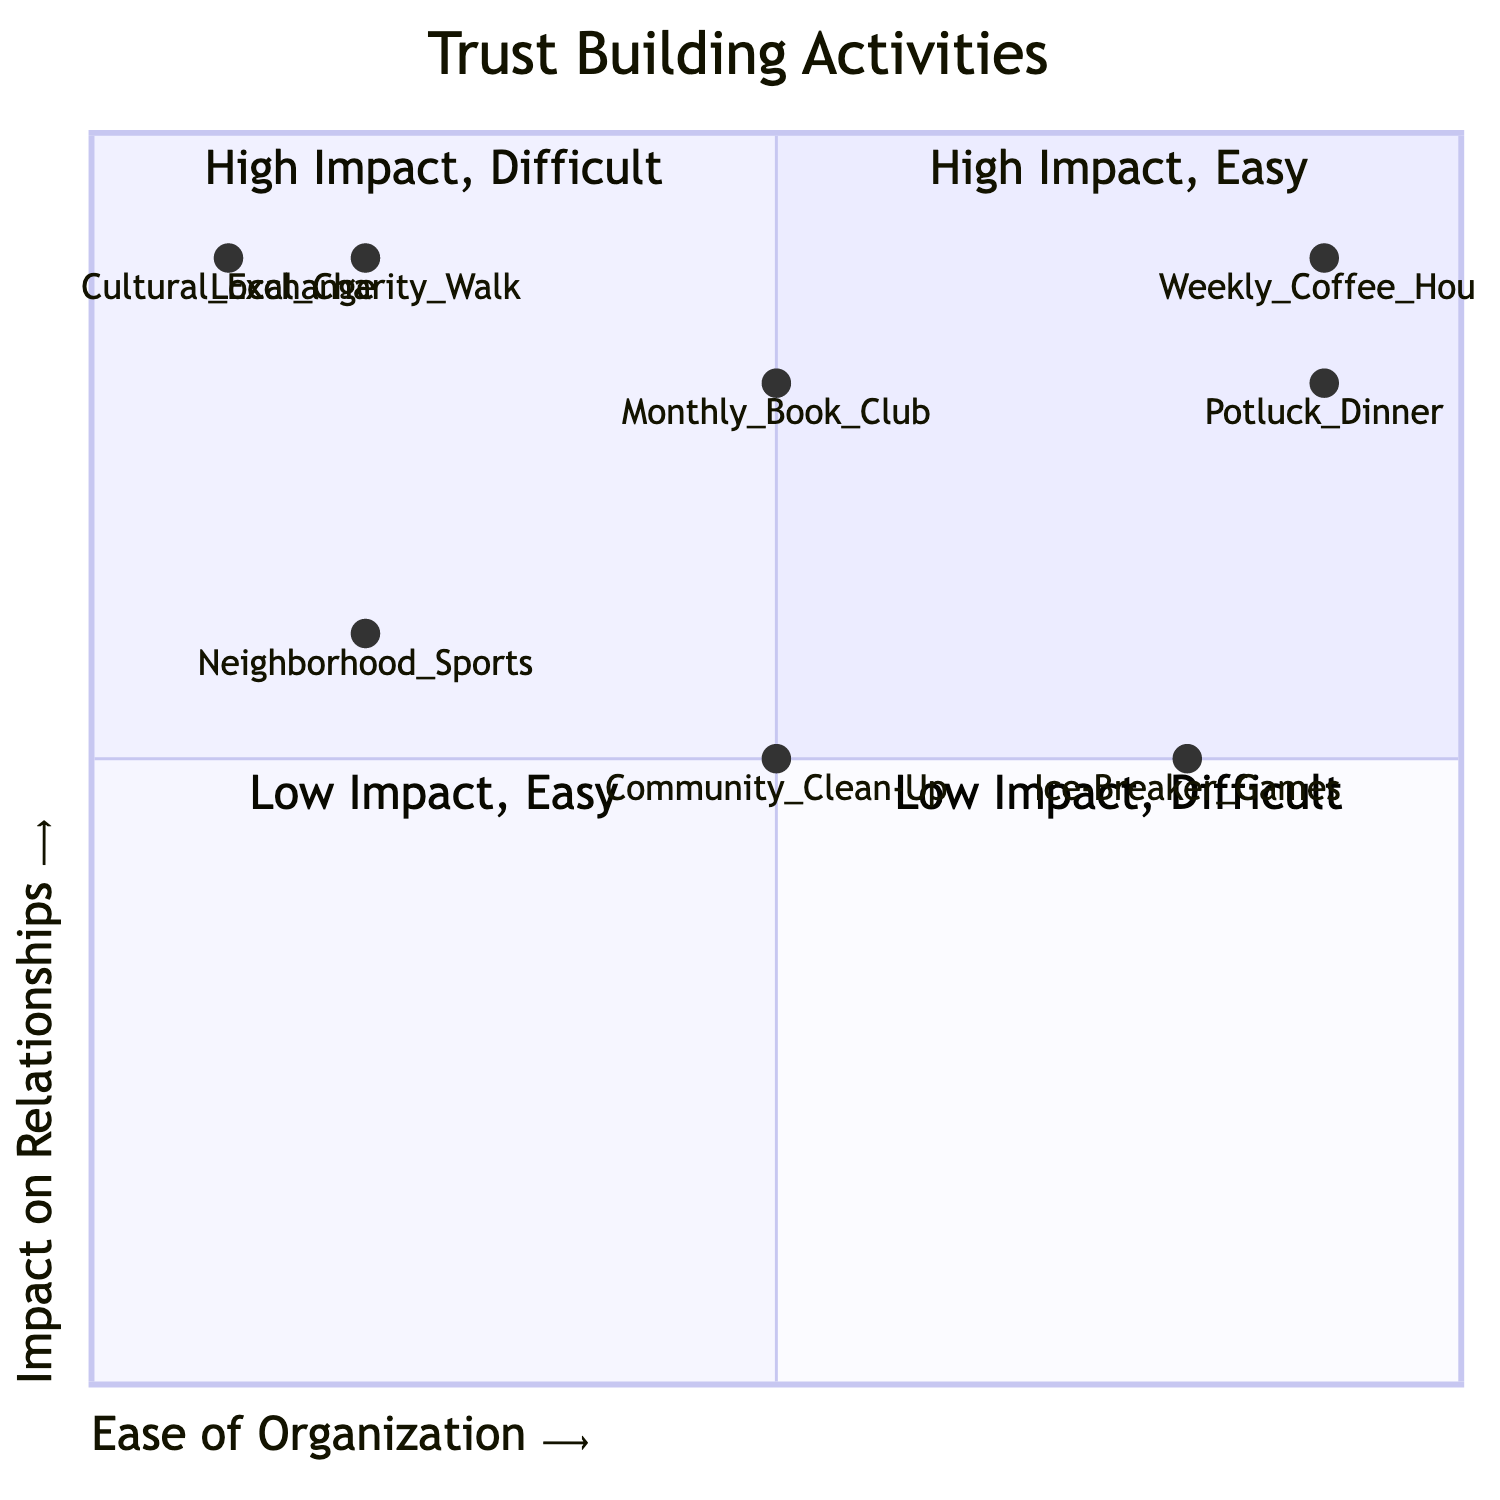What's the activity with the highest impact and easiest organization? The quadrant chart indicates that "Potluck Dinner" is located in the quadrant that represents high impact and easy organization. This can be confirmed by looking at the coordinates assigned to "Potluck Dinner" in the diagram, which place it clearly in that quadrant.
Answer: Potluck Dinner How many activities are classified as having high impact? By reviewing the chart, I count the activities in the "High Impact" quadrants (quadrant 1 and quadrant 2), which include "Potluck Dinner," "Local Charity Walk/Run," "Monthly Book Club," "Weekly Coffee Hour," and "Cultural Exchange Night." This totals five activities.
Answer: Five Which activity is the most challenging to organize with high impact? By assessing the chart, "Local Charity Walk/Run" and "Cultural Exchange Night" both fall into the quadrant for high impact but difficult organization. Comparing their impact levels shows that both are in the same position, but since we want the one that is most difficult to organize, "Local Charity Walk/Run" appears first in its category based on conventional understanding.
Answer: Local Charity Walk/Run What is the impact of "Community Clean-Up"? The chart displays "Community Clean-Up" in quadrant 3, indicating it has moderate impact. This can be verified by looking at the activity's placement in the quadrant which is categorized as low impact, but with moderate ease of organization.
Answer: Moderate Which activities fall within the "Low Impact, Easy" quadrant? The diagram does not show any activities placed in the "Low Impact, Easy" quadrant. By examining each of the activities and their assigned quadrants, it becomes clear that none fit that combination of impact and ease.
Answer: None Are there any activities with moderate impact that are easy to organize? The diagram shows "Ice-Breaker Games Session" in quadrant 3, indicating that it has moderate impact and is easy to organize. It is the only activity that meets both criteria upon inspection of the respective quadrant.
Answer: Ice-Breaker Games Session 